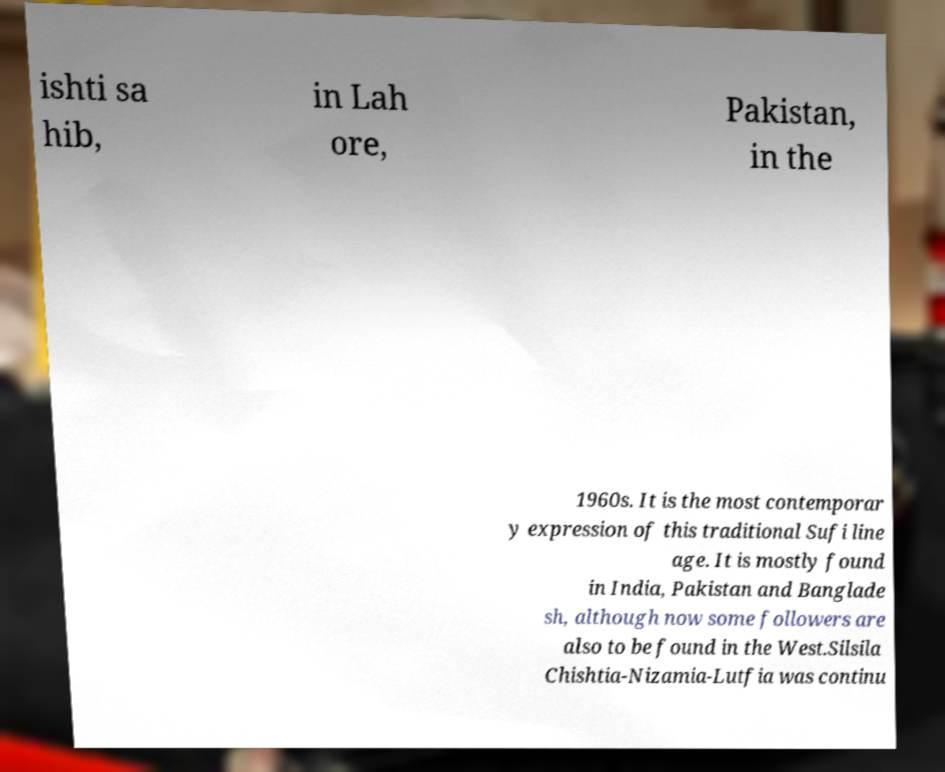Can you read and provide the text displayed in the image?This photo seems to have some interesting text. Can you extract and type it out for me? ishti sa hib, in Lah ore, Pakistan, in the 1960s. It is the most contemporar y expression of this traditional Sufi line age. It is mostly found in India, Pakistan and Banglade sh, although now some followers are also to be found in the West.Silsila Chishtia-Nizamia-Lutfia was continu 